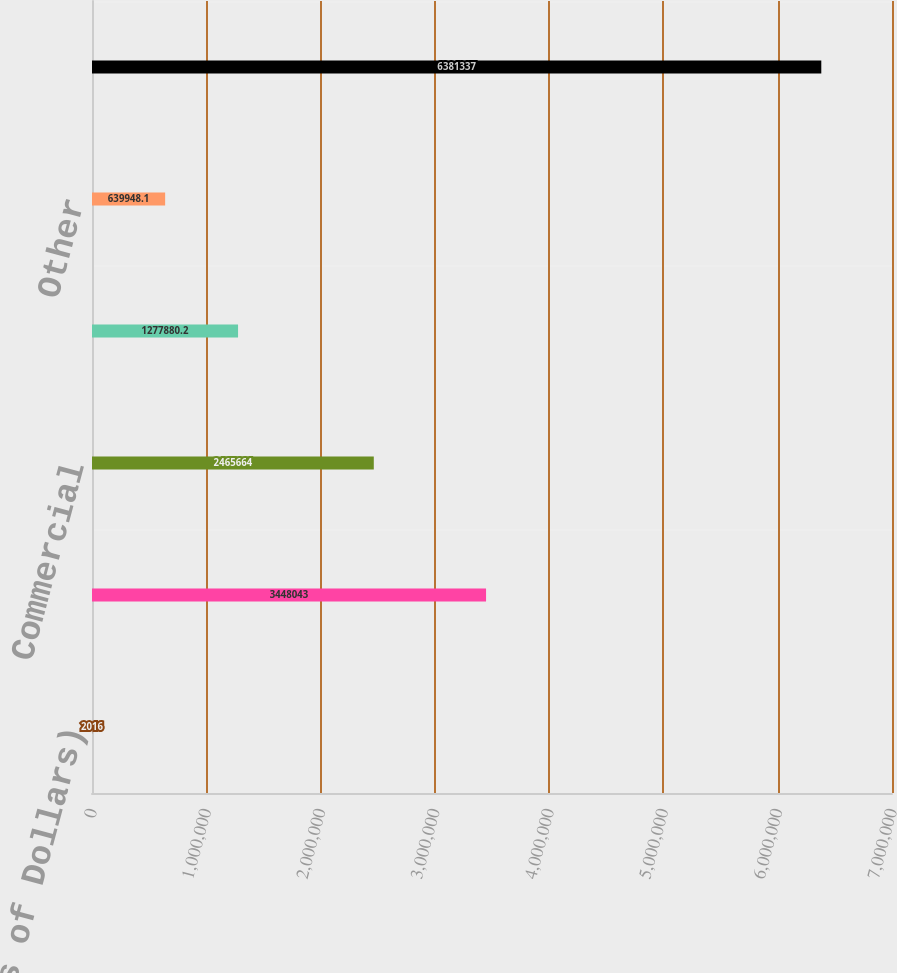Convert chart to OTSL. <chart><loc_0><loc_0><loc_500><loc_500><bar_chart><fcel>(Thousands of Dollars)<fcel>Residential<fcel>Commercial<fcel>Industrial<fcel>Other<fcel>Total Retail Electric Revenues<nl><fcel>2016<fcel>3.44804e+06<fcel>2.46566e+06<fcel>1.27788e+06<fcel>639948<fcel>6.38134e+06<nl></chart> 